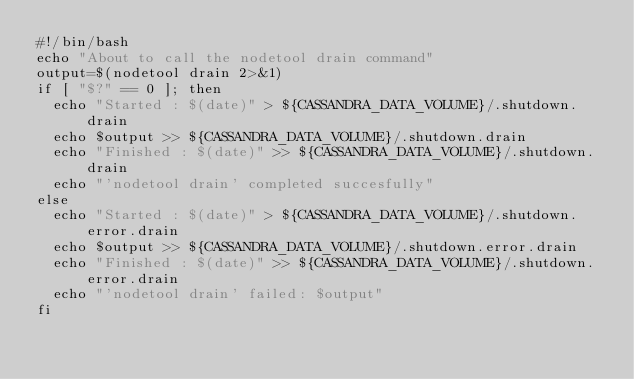<code> <loc_0><loc_0><loc_500><loc_500><_Bash_>#!/bin/bash
echo "About to call the nodetool drain command"
output=$(nodetool drain 2>&1)
if [ "$?" == 0 ]; then
  echo "Started : $(date)" > ${CASSANDRA_DATA_VOLUME}/.shutdown.drain
  echo $output >> ${CASSANDRA_DATA_VOLUME}/.shutdown.drain
  echo "Finished : $(date)" >> ${CASSANDRA_DATA_VOLUME}/.shutdown.drain
  echo "'nodetool drain' completed succesfully"
else
  echo "Started : $(date)" > ${CASSANDRA_DATA_VOLUME}/.shutdown.error.drain
  echo $output >> ${CASSANDRA_DATA_VOLUME}/.shutdown.error.drain
  echo "Finished : $(date)" >> ${CASSANDRA_DATA_VOLUME}/.shutdown.error.drain
  echo "'nodetool drain' failed: $output"
fi
</code> 